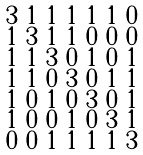<formula> <loc_0><loc_0><loc_500><loc_500>\begin{smallmatrix} 3 & 1 & 1 & 1 & 1 & 1 & 0 \\ 1 & 3 & 1 & 1 & 0 & 0 & 0 \\ 1 & 1 & 3 & 0 & 1 & 0 & 1 \\ 1 & 1 & 0 & 3 & 0 & 1 & 1 \\ 1 & 0 & 1 & 0 & 3 & 0 & 1 \\ 1 & 0 & 0 & 1 & 0 & 3 & 1 \\ 0 & 0 & 1 & 1 & 1 & 1 & 3 \end{smallmatrix}</formula> 